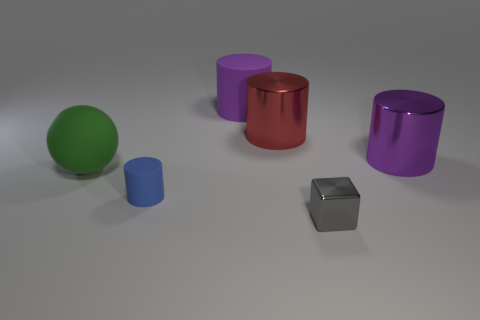What shape is the thing that is the same color as the big rubber cylinder?
Your answer should be compact. Cylinder. Do the big rubber thing right of the green sphere and the metallic cylinder to the right of the metallic block have the same color?
Make the answer very short. Yes. How many large objects have the same color as the large rubber cylinder?
Provide a succinct answer. 1. Is there anything else of the same color as the large matte cylinder?
Your answer should be compact. Yes. Does the thing that is on the left side of the small blue matte thing have the same size as the rubber cylinder that is in front of the red thing?
Provide a short and direct response. No. What is the shape of the metal thing that is in front of the large thing that is to the right of the red shiny cylinder?
Provide a short and direct response. Cube. Do the purple metallic object and the blue thing that is to the left of the metallic block have the same size?
Provide a short and direct response. No. There is a purple thing right of the purple thing that is behind the metallic thing that is to the left of the small metallic thing; what size is it?
Give a very brief answer. Large. What number of objects are shiny things that are in front of the big green ball or large red shiny things?
Your answer should be compact. 2. There is a purple shiny cylinder right of the red shiny cylinder; how many purple cylinders are on the left side of it?
Your answer should be compact. 1. 